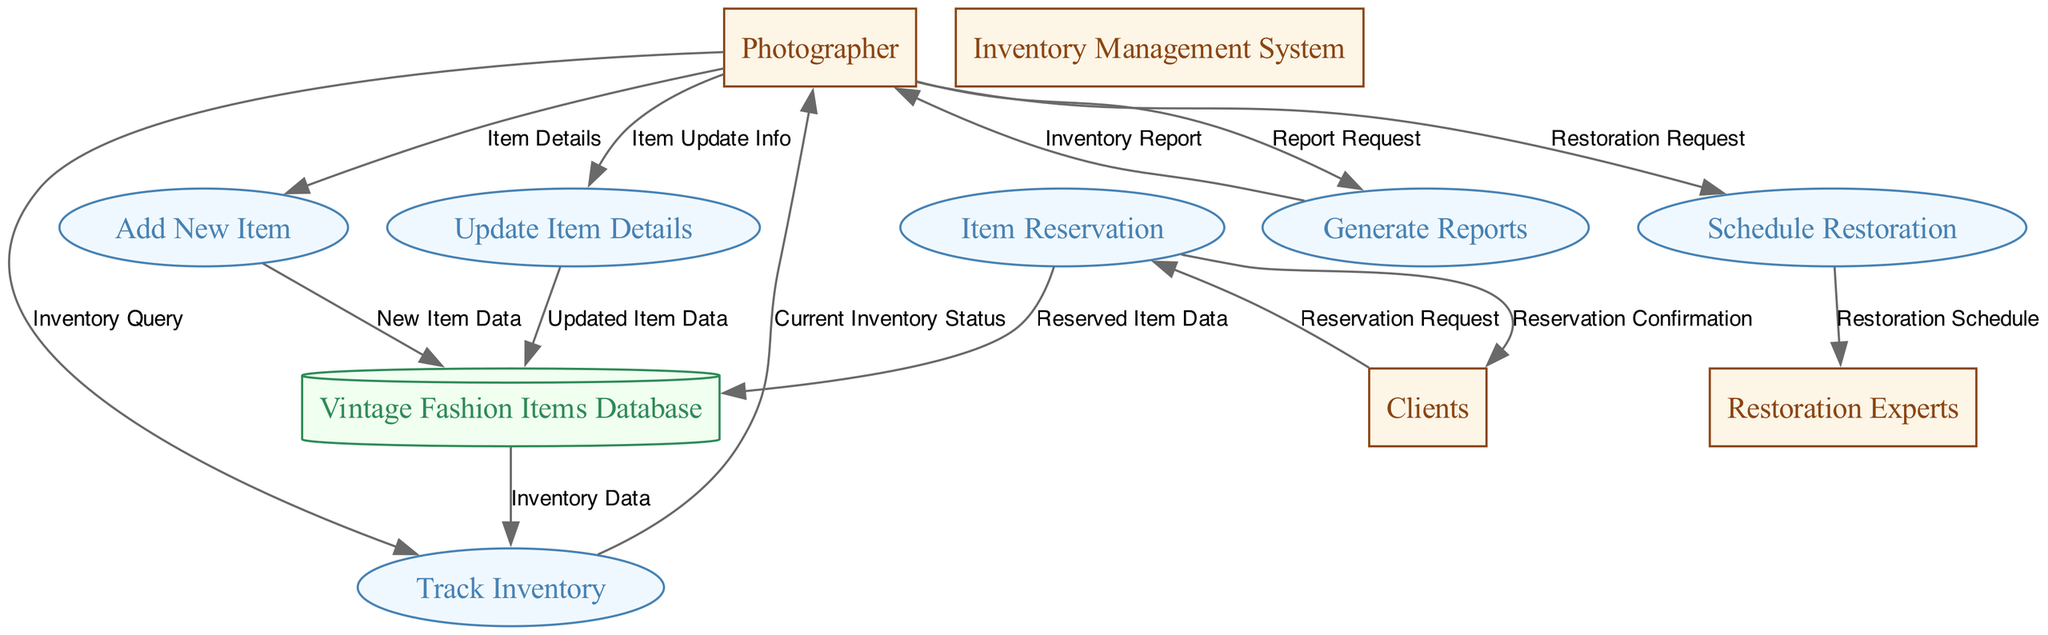What process is responsible for adding new items to the inventory? The diagram indicates the process labeled "Add New Item" is responsible for adding new items to the inventory. This is shown as an input from the "Photographer" to the respective process.
Answer: Add New Item How many external entities are represented in the diagram? When counting the boxes labeled as external entities, we find "Photographer," "Restoration Experts," and "Clients," totaling three external entities in the diagram.
Answer: 3 What data is transferred from "Track Inventory" to "Photographer"? The data flow from "Track Inventory" to "Photographer" is labeled "Current Inventory Status," which signifies the information being communicated back to the photographer.
Answer: Current Inventory Status Which process handles the scheduling of restorations? The process labeled "Schedule Restoration" is specifically tasked with managing the schedules for restorations according to the diagram.
Answer: Schedule Restoration What entity receives confirmation after item reservations are made? According to the diagram, the flow labeled "Reservation Confirmation" indicates that confirmations are sent to "Clients" after their reservation requests are processed.
Answer: Clients Which data flow connects "Generate Reports" back to the "Photographer"? The label of the data flow that connects "Generate Reports" back to the "Photographer" is "Inventory Report," which presents the final output of the report generation process.
Answer: Inventory Report How many processes are involved in the inventory management system? A count of the processes listed reveals there are six processes: "Add New Item," "Update Item Details," "Track Inventory," "Generate Reports," "Schedule Restoration," and "Item Reservation."
Answer: 6 What type of information does the "Photographer" provide to the "Update Item Details" process? The "Photographer" supplies "Item Update Info" to the "Update Item Details" process, indicating the type of data exchanged for updating item details in the system.
Answer: Item Update Info Which external entity interacts with the "Item Reservation" process? The "Clients" entity is directly linked with the "Item Reservation" process as they make reservation requests to the system, as indicated in the associated data flow.
Answer: Clients 